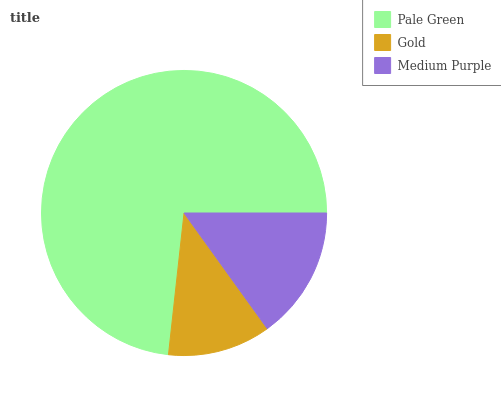Is Gold the minimum?
Answer yes or no. Yes. Is Pale Green the maximum?
Answer yes or no. Yes. Is Medium Purple the minimum?
Answer yes or no. No. Is Medium Purple the maximum?
Answer yes or no. No. Is Medium Purple greater than Gold?
Answer yes or no. Yes. Is Gold less than Medium Purple?
Answer yes or no. Yes. Is Gold greater than Medium Purple?
Answer yes or no. No. Is Medium Purple less than Gold?
Answer yes or no. No. Is Medium Purple the high median?
Answer yes or no. Yes. Is Medium Purple the low median?
Answer yes or no. Yes. Is Gold the high median?
Answer yes or no. No. Is Pale Green the low median?
Answer yes or no. No. 